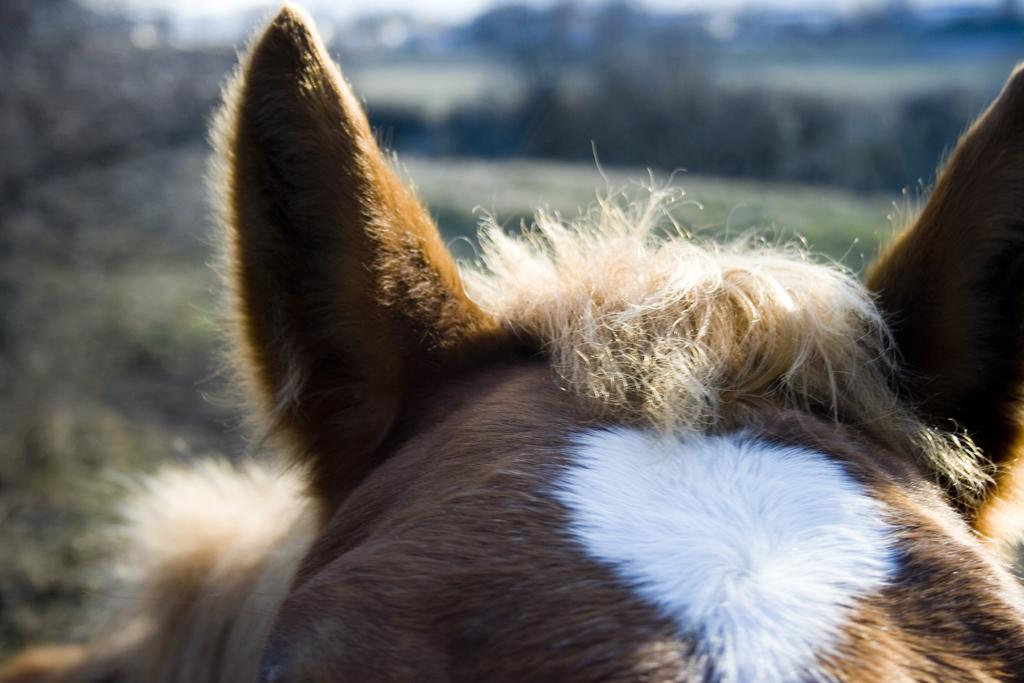What body parts are visible in the image? There are two ears visible in the image. What type of hair can be seen on the animal in the image? There is hair on the head of an animal in the image. What type of steel is used to make the dolls in the image? There are no dolls present in the image, and therefore no steel is used to make them. Where is the pocket located on the animal in the image? There is no pocket visible on the animal in the image. 